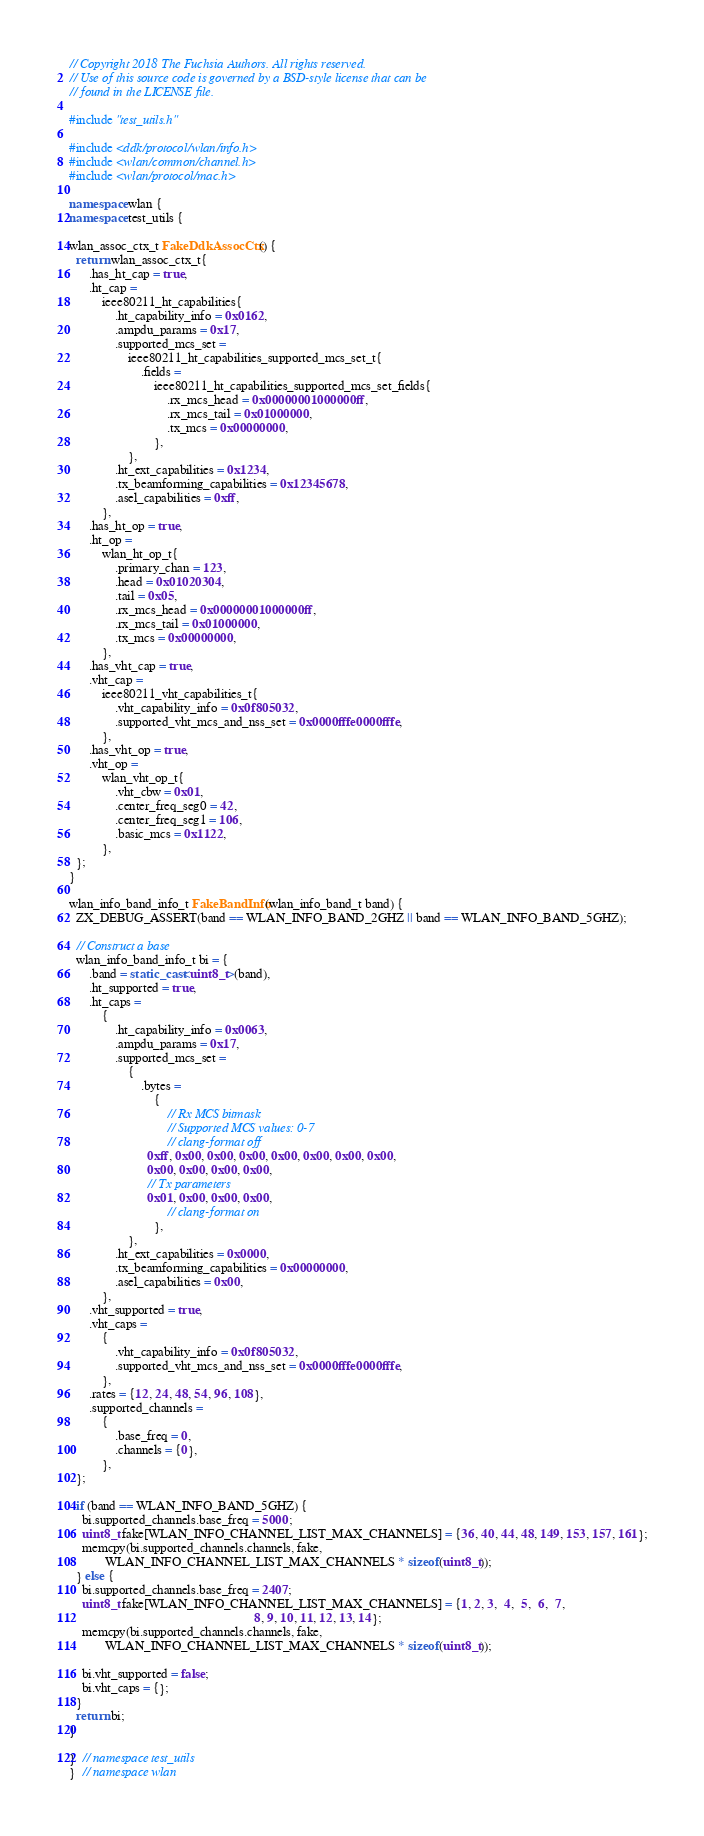Convert code to text. <code><loc_0><loc_0><loc_500><loc_500><_C++_>// Copyright 2018 The Fuchsia Authors. All rights reserved.
// Use of this source code is governed by a BSD-style license that can be
// found in the LICENSE file.

#include "test_utils.h"

#include <ddk/protocol/wlan/info.h>
#include <wlan/common/channel.h>
#include <wlan/protocol/mac.h>

namespace wlan {
namespace test_utils {

wlan_assoc_ctx_t FakeDdkAssocCtx() {
  return wlan_assoc_ctx_t{
      .has_ht_cap = true,
      .ht_cap =
          ieee80211_ht_capabilities{
              .ht_capability_info = 0x0162,
              .ampdu_params = 0x17,
              .supported_mcs_set =
                  ieee80211_ht_capabilities_supported_mcs_set_t{
                      .fields =
                          ieee80211_ht_capabilities_supported_mcs_set_fields{
                              .rx_mcs_head = 0x00000001000000ff,
                              .rx_mcs_tail = 0x01000000,
                              .tx_mcs = 0x00000000,
                          },
                  },
              .ht_ext_capabilities = 0x1234,
              .tx_beamforming_capabilities = 0x12345678,
              .asel_capabilities = 0xff,
          },
      .has_ht_op = true,
      .ht_op =
          wlan_ht_op_t{
              .primary_chan = 123,
              .head = 0x01020304,
              .tail = 0x05,
              .rx_mcs_head = 0x00000001000000ff,
              .rx_mcs_tail = 0x01000000,
              .tx_mcs = 0x00000000,
          },
      .has_vht_cap = true,
      .vht_cap =
          ieee80211_vht_capabilities_t{
              .vht_capability_info = 0x0f805032,
              .supported_vht_mcs_and_nss_set = 0x0000fffe0000fffe,
          },
      .has_vht_op = true,
      .vht_op =
          wlan_vht_op_t{
              .vht_cbw = 0x01,
              .center_freq_seg0 = 42,
              .center_freq_seg1 = 106,
              .basic_mcs = 0x1122,
          },
  };
}

wlan_info_band_info_t FakeBandInfo(wlan_info_band_t band) {
  ZX_DEBUG_ASSERT(band == WLAN_INFO_BAND_2GHZ || band == WLAN_INFO_BAND_5GHZ);

  // Construct a base
  wlan_info_band_info_t bi = {
      .band = static_cast<uint8_t>(band),
      .ht_supported = true,
      .ht_caps =
          {
              .ht_capability_info = 0x0063,
              .ampdu_params = 0x17,
              .supported_mcs_set =
                  {
                      .bytes =
                          {
                              // Rx MCS bitmask
                              // Supported MCS values: 0-7
                              // clang-format off
                        0xff, 0x00, 0x00, 0x00, 0x00, 0x00, 0x00, 0x00,
                        0x00, 0x00, 0x00, 0x00,
                        // Tx parameters
                        0x01, 0x00, 0x00, 0x00,
                              // clang-format on
                          },
                  },
              .ht_ext_capabilities = 0x0000,
              .tx_beamforming_capabilities = 0x00000000,
              .asel_capabilities = 0x00,
          },
      .vht_supported = true,
      .vht_caps =
          {
              .vht_capability_info = 0x0f805032,
              .supported_vht_mcs_and_nss_set = 0x0000fffe0000fffe,
          },
      .rates = {12, 24, 48, 54, 96, 108},
      .supported_channels =
          {
              .base_freq = 0,
              .channels = {0},
          },
  };

  if (band == WLAN_INFO_BAND_5GHZ) {
    bi.supported_channels.base_freq = 5000;
    uint8_t fake[WLAN_INFO_CHANNEL_LIST_MAX_CHANNELS] = {36, 40, 44, 48, 149, 153, 157, 161};
    memcpy(bi.supported_channels.channels, fake,
           WLAN_INFO_CHANNEL_LIST_MAX_CHANNELS * sizeof(uint8_t));
  } else {
    bi.supported_channels.base_freq = 2407;
    uint8_t fake[WLAN_INFO_CHANNEL_LIST_MAX_CHANNELS] = {1, 2, 3,  4,  5,  6,  7,
                                                         8, 9, 10, 11, 12, 13, 14};
    memcpy(bi.supported_channels.channels, fake,
           WLAN_INFO_CHANNEL_LIST_MAX_CHANNELS * sizeof(uint8_t));

    bi.vht_supported = false;
    bi.vht_caps = {};
  }
  return bi;
}

}  // namespace test_utils
}  // namespace wlan
</code> 